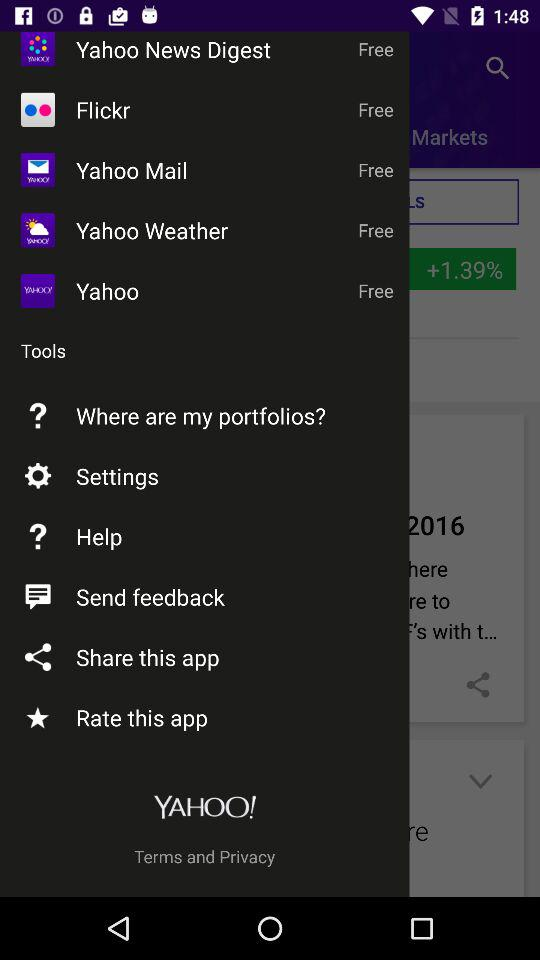Is "Yahoo Mail" free or paid? "Yahoo Mail" is free. 